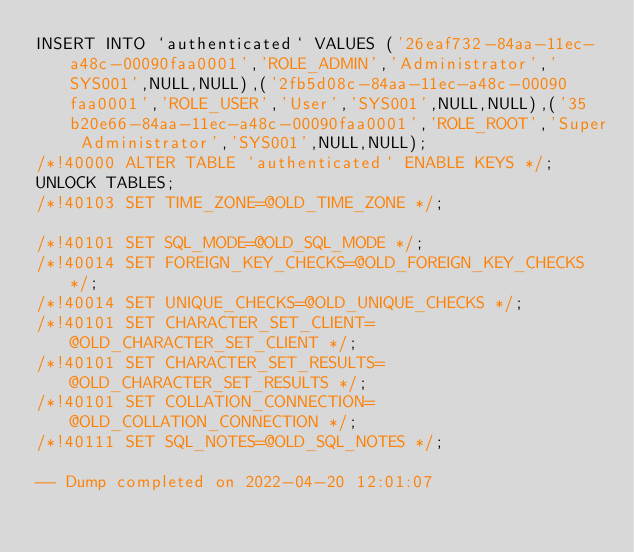<code> <loc_0><loc_0><loc_500><loc_500><_SQL_>INSERT INTO `authenticated` VALUES ('26eaf732-84aa-11ec-a48c-00090faa0001','ROLE_ADMIN','Administrator','SYS001',NULL,NULL),('2fb5d08c-84aa-11ec-a48c-00090faa0001','ROLE_USER','User','SYS001',NULL,NULL),('35b20e66-84aa-11ec-a48c-00090faa0001','ROLE_ROOT','Super Administrator','SYS001',NULL,NULL);
/*!40000 ALTER TABLE `authenticated` ENABLE KEYS */;
UNLOCK TABLES;
/*!40103 SET TIME_ZONE=@OLD_TIME_ZONE */;

/*!40101 SET SQL_MODE=@OLD_SQL_MODE */;
/*!40014 SET FOREIGN_KEY_CHECKS=@OLD_FOREIGN_KEY_CHECKS */;
/*!40014 SET UNIQUE_CHECKS=@OLD_UNIQUE_CHECKS */;
/*!40101 SET CHARACTER_SET_CLIENT=@OLD_CHARACTER_SET_CLIENT */;
/*!40101 SET CHARACTER_SET_RESULTS=@OLD_CHARACTER_SET_RESULTS */;
/*!40101 SET COLLATION_CONNECTION=@OLD_COLLATION_CONNECTION */;
/*!40111 SET SQL_NOTES=@OLD_SQL_NOTES */;

-- Dump completed on 2022-04-20 12:01:07
</code> 